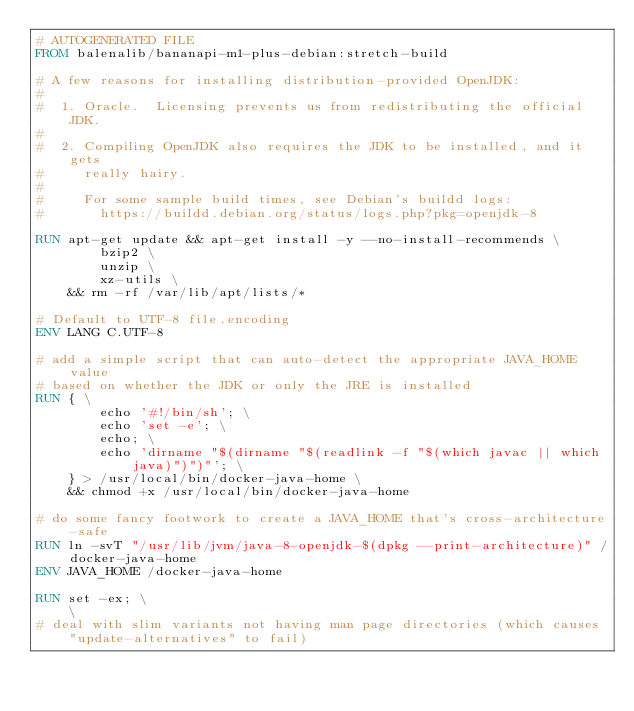Convert code to text. <code><loc_0><loc_0><loc_500><loc_500><_Dockerfile_># AUTOGENERATED FILE
FROM balenalib/bananapi-m1-plus-debian:stretch-build

# A few reasons for installing distribution-provided OpenJDK:
#
#  1. Oracle.  Licensing prevents us from redistributing the official JDK.
#
#  2. Compiling OpenJDK also requires the JDK to be installed, and it gets
#     really hairy.
#
#     For some sample build times, see Debian's buildd logs:
#       https://buildd.debian.org/status/logs.php?pkg=openjdk-8

RUN apt-get update && apt-get install -y --no-install-recommends \
		bzip2 \
		unzip \
		xz-utils \
	&& rm -rf /var/lib/apt/lists/*

# Default to UTF-8 file.encoding
ENV LANG C.UTF-8

# add a simple script that can auto-detect the appropriate JAVA_HOME value
# based on whether the JDK or only the JRE is installed
RUN { \
		echo '#!/bin/sh'; \
		echo 'set -e'; \
		echo; \
		echo 'dirname "$(dirname "$(readlink -f "$(which javac || which java)")")"'; \
	} > /usr/local/bin/docker-java-home \
	&& chmod +x /usr/local/bin/docker-java-home

# do some fancy footwork to create a JAVA_HOME that's cross-architecture-safe
RUN ln -svT "/usr/lib/jvm/java-8-openjdk-$(dpkg --print-architecture)" /docker-java-home
ENV JAVA_HOME /docker-java-home

RUN set -ex; \
	\
# deal with slim variants not having man page directories (which causes "update-alternatives" to fail)</code> 